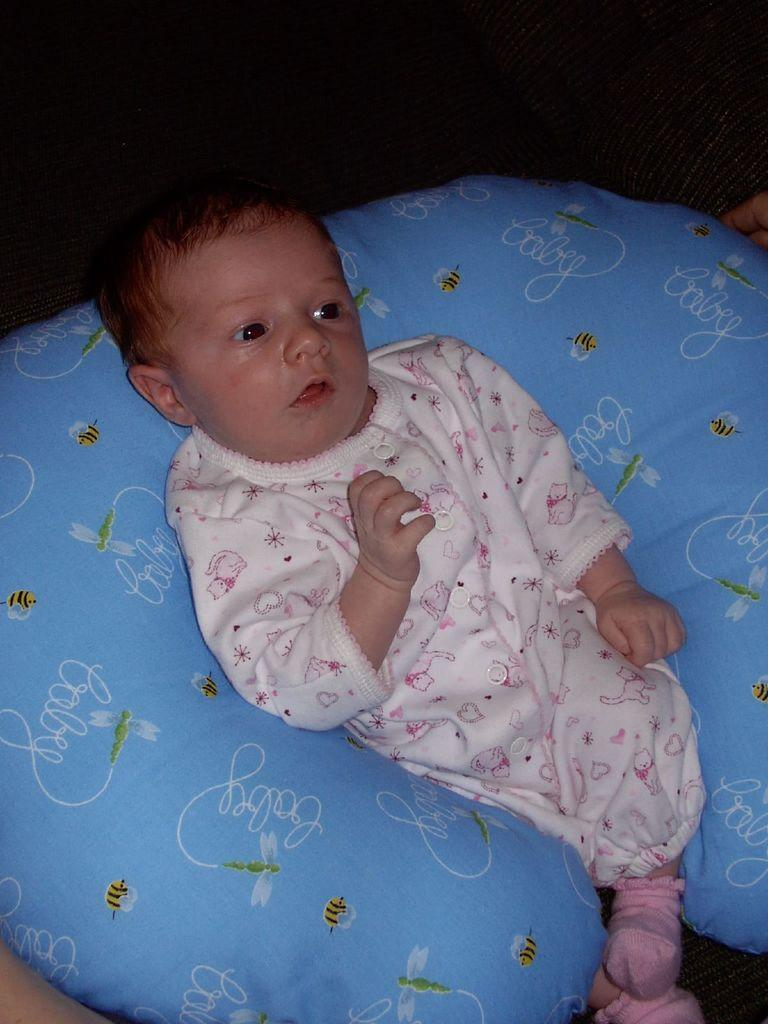What is the main subject of the image? There is a baby in the image. What is the baby lying on? The baby is on a blue color bed. What is the baby wearing? The baby is wearing a white and pink color dress and pink socks. What color is the background of the image? The background of the image is black. Can you tell me how many cans of soda are on the bed with the baby? There are no cans of soda present in the image; it only features a baby on a blue color bed. What type of medical equipment can be seen in the image? There is no medical equipment present in the image; it only features a baby on a blue color bed. 